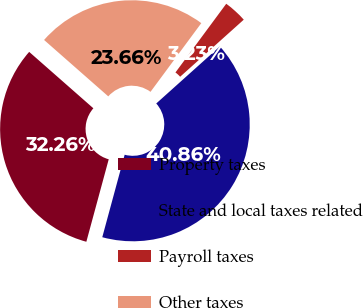Convert chart. <chart><loc_0><loc_0><loc_500><loc_500><pie_chart><fcel>Property taxes<fcel>State and local taxes related<fcel>Payroll taxes<fcel>Other taxes<nl><fcel>32.26%<fcel>40.86%<fcel>3.23%<fcel>23.66%<nl></chart> 